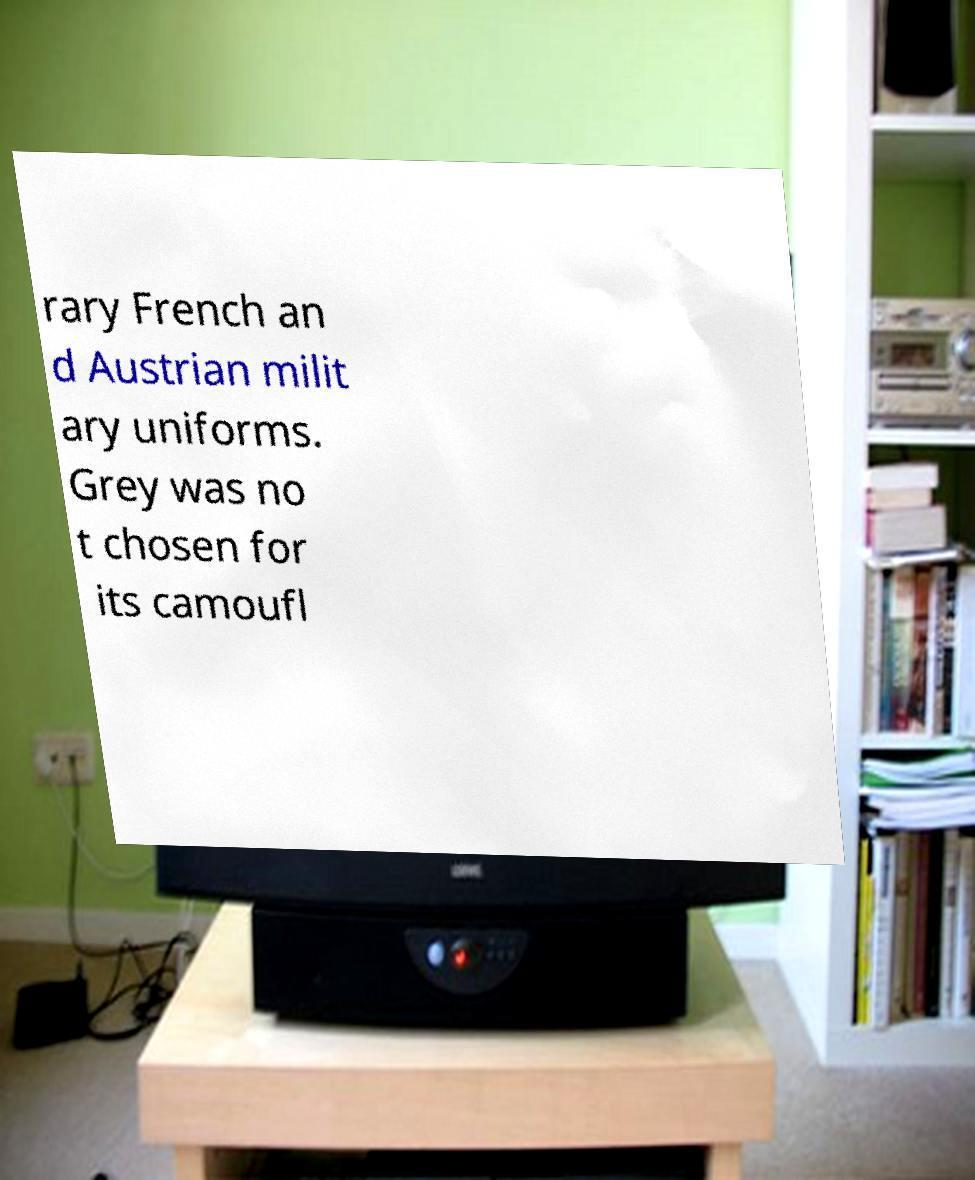Please read and relay the text visible in this image. What does it say? rary French an d Austrian milit ary uniforms. Grey was no t chosen for its camoufl 